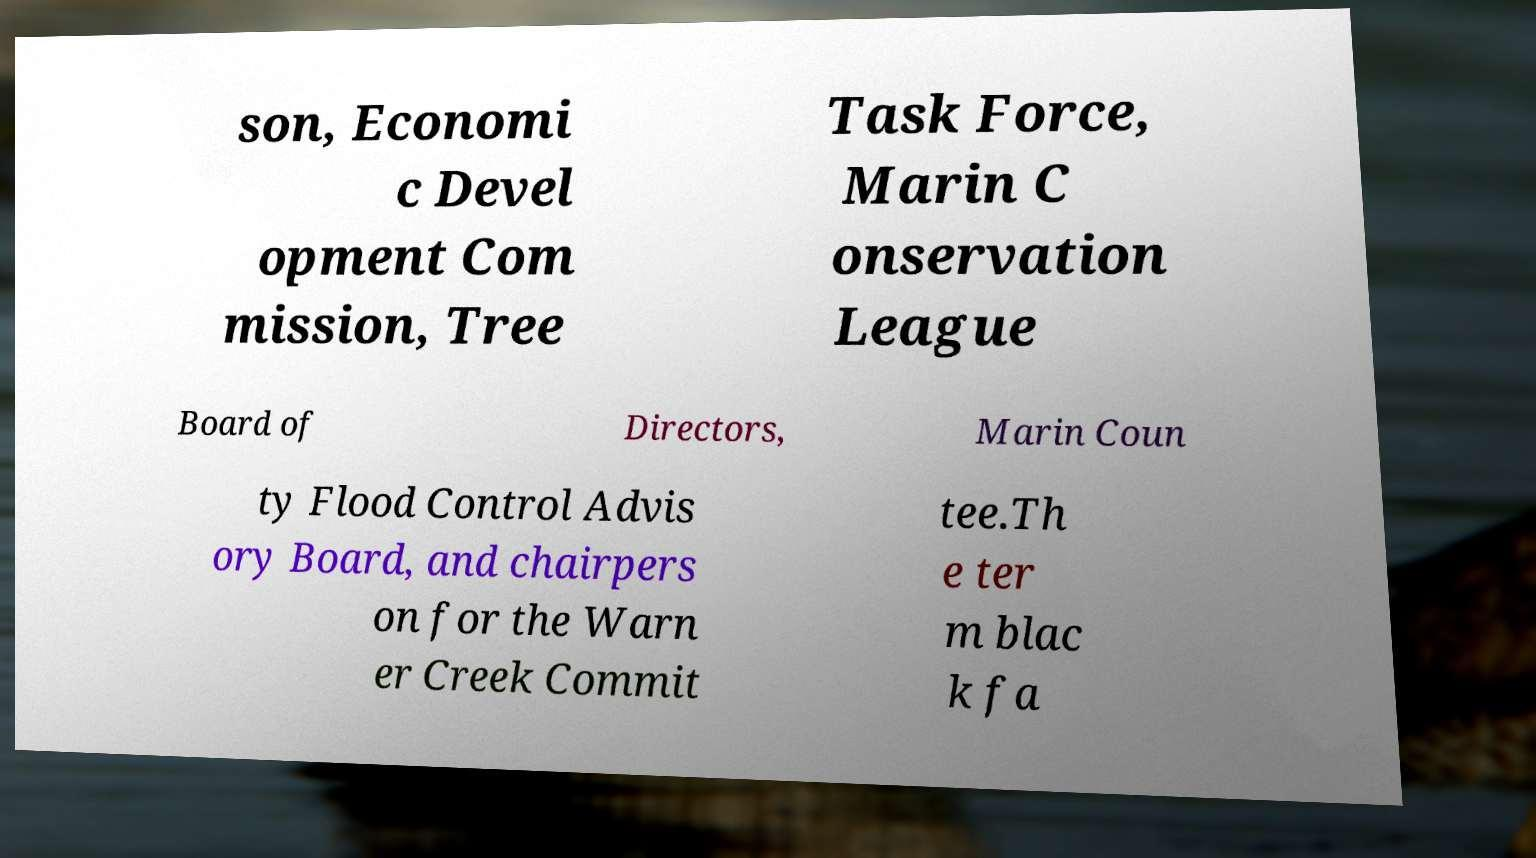Could you extract and type out the text from this image? son, Economi c Devel opment Com mission, Tree Task Force, Marin C onservation League Board of Directors, Marin Coun ty Flood Control Advis ory Board, and chairpers on for the Warn er Creek Commit tee.Th e ter m blac k fa 